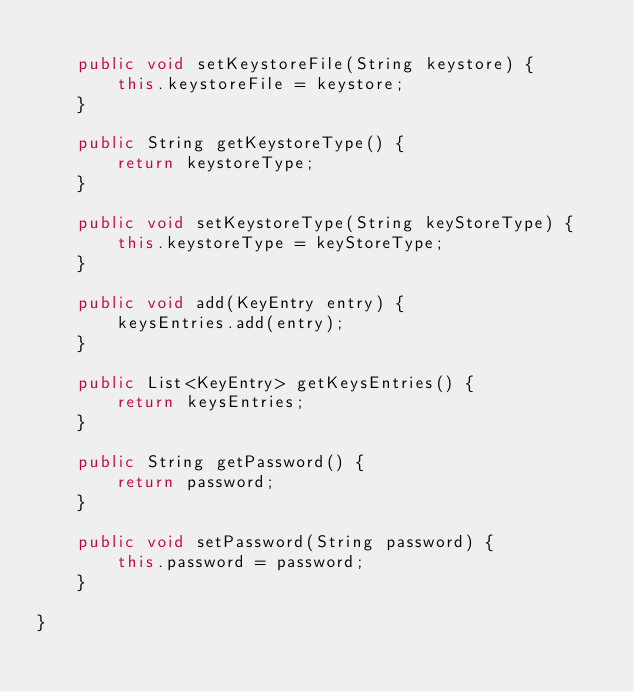Convert code to text. <code><loc_0><loc_0><loc_500><loc_500><_Java_>
    public void setKeystoreFile(String keystore) {
        this.keystoreFile = keystore;
    }

    public String getKeystoreType() {
        return keystoreType;
    }

    public void setKeystoreType(String keyStoreType) {
        this.keystoreType = keyStoreType;
    }

    public void add(KeyEntry entry) {
        keysEntries.add(entry);
    }

    public List<KeyEntry> getKeysEntries() {
        return keysEntries;
    }

    public String getPassword() {
        return password;
    }

    public void setPassword(String password) {
        this.password = password;
    }
    
}
</code> 